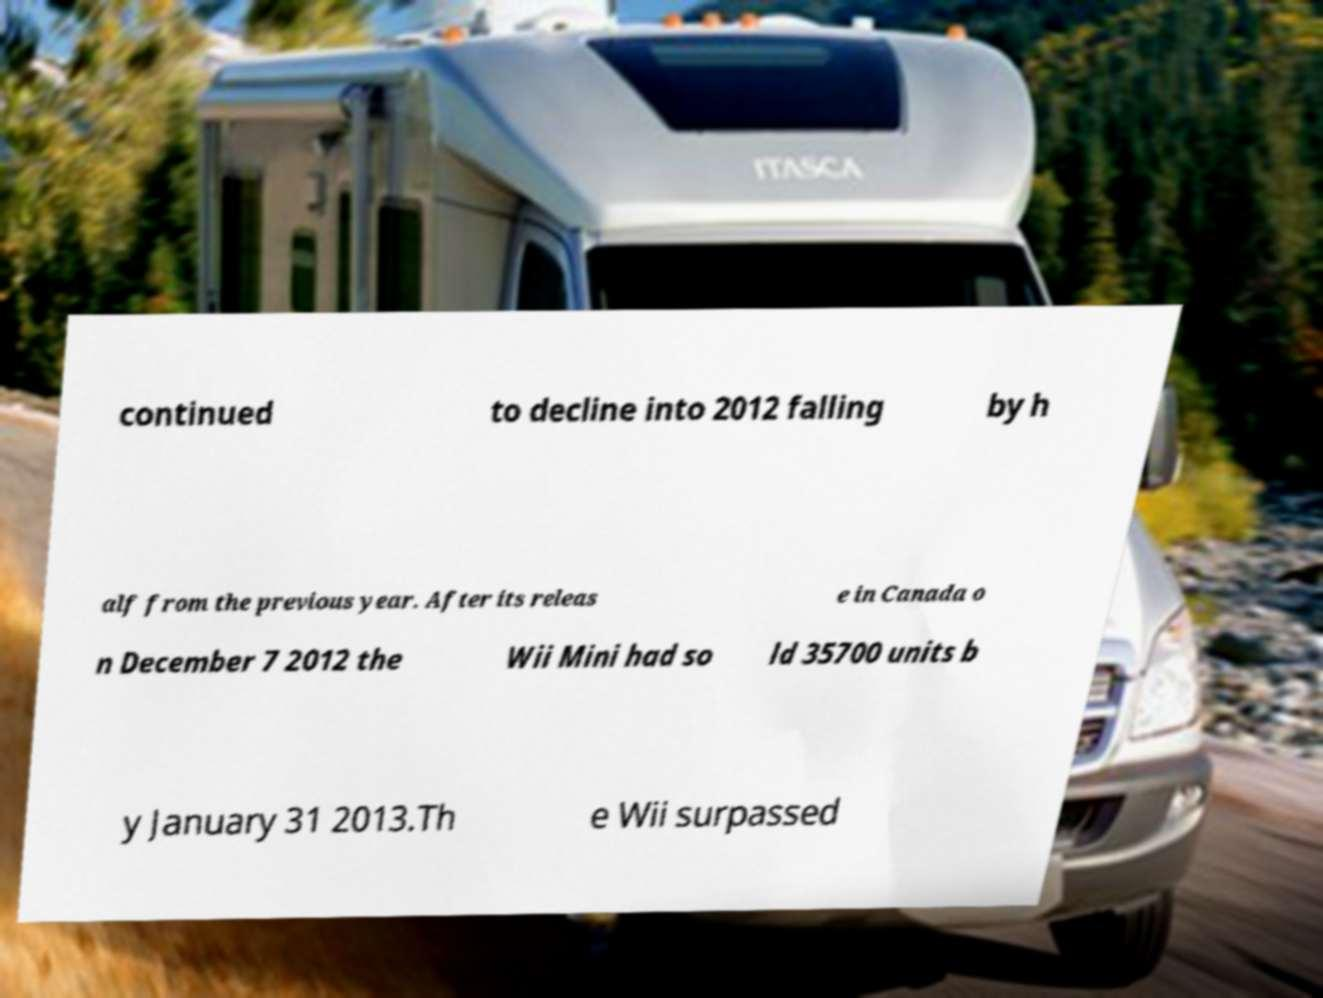Please identify and transcribe the text found in this image. continued to decline into 2012 falling by h alf from the previous year. After its releas e in Canada o n December 7 2012 the Wii Mini had so ld 35700 units b y January 31 2013.Th e Wii surpassed 